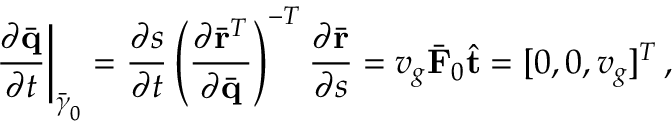<formula> <loc_0><loc_0><loc_500><loc_500>\frac { \partial \bar { q } } { \partial t } \right | _ { \bar { \gamma } _ { 0 } } = \frac { \partial s } { \partial t } \left ( \frac { \partial \bar { r } ^ { T } } { \partial \bar { q } } \right ) ^ { - T } \frac { \partial \bar { r } } { \partial s } = v _ { g } \bar { F } _ { 0 } \hat { t } = [ 0 , 0 , v _ { g } ] ^ { T } \, ,</formula> 